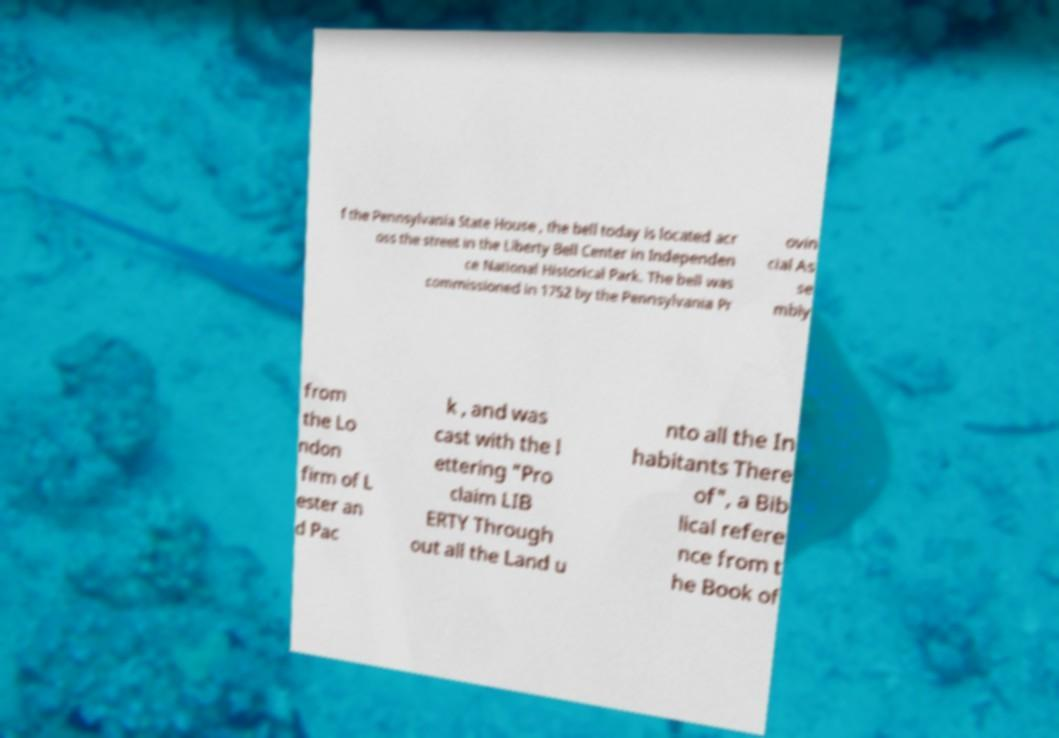Can you read and provide the text displayed in the image?This photo seems to have some interesting text. Can you extract and type it out for me? f the Pennsylvania State House , the bell today is located acr oss the street in the Liberty Bell Center in Independen ce National Historical Park. The bell was commissioned in 1752 by the Pennsylvania Pr ovin cial As se mbly from the Lo ndon firm of L ester an d Pac k , and was cast with the l ettering "Pro claim LIB ERTY Through out all the Land u nto all the In habitants There of", a Bib lical refere nce from t he Book of 